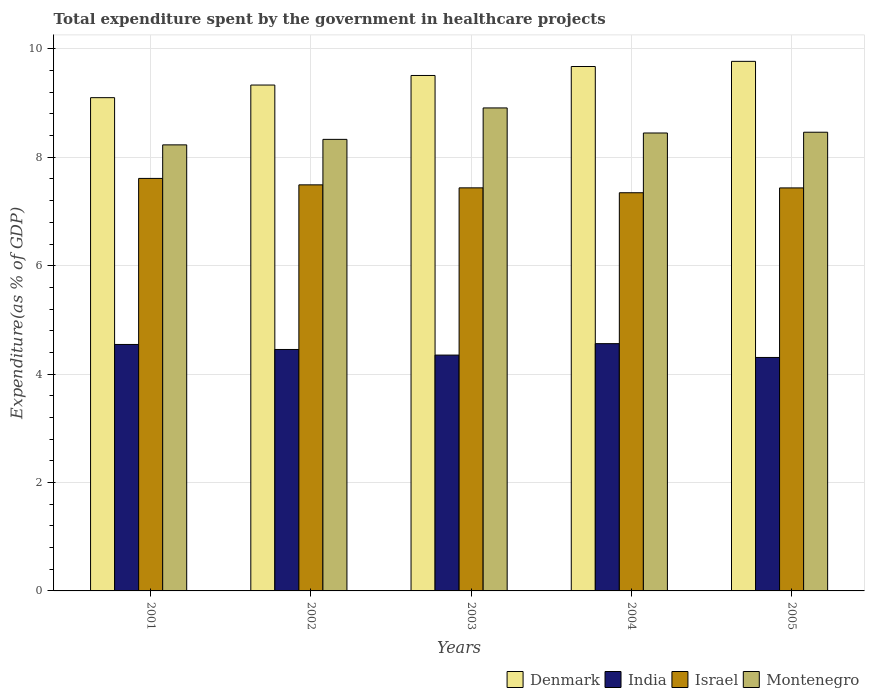How many bars are there on the 4th tick from the left?
Make the answer very short. 4. How many bars are there on the 4th tick from the right?
Offer a very short reply. 4. What is the total expenditure spent by the government in healthcare projects in Montenegro in 2001?
Provide a succinct answer. 8.23. Across all years, what is the maximum total expenditure spent by the government in healthcare projects in Montenegro?
Your answer should be very brief. 8.91. Across all years, what is the minimum total expenditure spent by the government in healthcare projects in Denmark?
Offer a very short reply. 9.1. In which year was the total expenditure spent by the government in healthcare projects in India maximum?
Keep it short and to the point. 2004. In which year was the total expenditure spent by the government in healthcare projects in Israel minimum?
Make the answer very short. 2004. What is the total total expenditure spent by the government in healthcare projects in India in the graph?
Provide a succinct answer. 22.22. What is the difference between the total expenditure spent by the government in healthcare projects in Israel in 2002 and that in 2005?
Give a very brief answer. 0.06. What is the difference between the total expenditure spent by the government in healthcare projects in India in 2003 and the total expenditure spent by the government in healthcare projects in Denmark in 2001?
Your response must be concise. -4.75. What is the average total expenditure spent by the government in healthcare projects in Denmark per year?
Provide a succinct answer. 9.48. In the year 2005, what is the difference between the total expenditure spent by the government in healthcare projects in Montenegro and total expenditure spent by the government in healthcare projects in Israel?
Offer a terse response. 1.03. What is the ratio of the total expenditure spent by the government in healthcare projects in Montenegro in 2004 to that in 2005?
Keep it short and to the point. 1. What is the difference between the highest and the second highest total expenditure spent by the government in healthcare projects in Denmark?
Make the answer very short. 0.1. What is the difference between the highest and the lowest total expenditure spent by the government in healthcare projects in Israel?
Keep it short and to the point. 0.26. Is the sum of the total expenditure spent by the government in healthcare projects in Denmark in 2002 and 2005 greater than the maximum total expenditure spent by the government in healthcare projects in India across all years?
Offer a terse response. Yes. What does the 1st bar from the left in 2004 represents?
Keep it short and to the point. Denmark. How many bars are there?
Give a very brief answer. 20. What is the difference between two consecutive major ticks on the Y-axis?
Offer a terse response. 2. Are the values on the major ticks of Y-axis written in scientific E-notation?
Your answer should be very brief. No. Does the graph contain any zero values?
Your answer should be very brief. No. Does the graph contain grids?
Offer a terse response. Yes. Where does the legend appear in the graph?
Ensure brevity in your answer.  Bottom right. How many legend labels are there?
Give a very brief answer. 4. What is the title of the graph?
Offer a terse response. Total expenditure spent by the government in healthcare projects. Does "Afghanistan" appear as one of the legend labels in the graph?
Keep it short and to the point. No. What is the label or title of the Y-axis?
Provide a succinct answer. Expenditure(as % of GDP). What is the Expenditure(as % of GDP) of Denmark in 2001?
Offer a terse response. 9.1. What is the Expenditure(as % of GDP) in India in 2001?
Your answer should be very brief. 4.55. What is the Expenditure(as % of GDP) in Israel in 2001?
Your response must be concise. 7.61. What is the Expenditure(as % of GDP) in Montenegro in 2001?
Your response must be concise. 8.23. What is the Expenditure(as % of GDP) of Denmark in 2002?
Keep it short and to the point. 9.33. What is the Expenditure(as % of GDP) of India in 2002?
Your answer should be compact. 4.45. What is the Expenditure(as % of GDP) in Israel in 2002?
Provide a short and direct response. 7.49. What is the Expenditure(as % of GDP) in Montenegro in 2002?
Ensure brevity in your answer.  8.33. What is the Expenditure(as % of GDP) in Denmark in 2003?
Make the answer very short. 9.51. What is the Expenditure(as % of GDP) of India in 2003?
Give a very brief answer. 4.35. What is the Expenditure(as % of GDP) in Israel in 2003?
Ensure brevity in your answer.  7.44. What is the Expenditure(as % of GDP) in Montenegro in 2003?
Keep it short and to the point. 8.91. What is the Expenditure(as % of GDP) of Denmark in 2004?
Your answer should be very brief. 9.67. What is the Expenditure(as % of GDP) of India in 2004?
Provide a succinct answer. 4.56. What is the Expenditure(as % of GDP) in Israel in 2004?
Your response must be concise. 7.35. What is the Expenditure(as % of GDP) in Montenegro in 2004?
Keep it short and to the point. 8.45. What is the Expenditure(as % of GDP) of Denmark in 2005?
Your response must be concise. 9.77. What is the Expenditure(as % of GDP) of India in 2005?
Your answer should be very brief. 4.31. What is the Expenditure(as % of GDP) of Israel in 2005?
Offer a very short reply. 7.44. What is the Expenditure(as % of GDP) of Montenegro in 2005?
Keep it short and to the point. 8.46. Across all years, what is the maximum Expenditure(as % of GDP) in Denmark?
Make the answer very short. 9.77. Across all years, what is the maximum Expenditure(as % of GDP) in India?
Your answer should be very brief. 4.56. Across all years, what is the maximum Expenditure(as % of GDP) in Israel?
Offer a terse response. 7.61. Across all years, what is the maximum Expenditure(as % of GDP) in Montenegro?
Provide a short and direct response. 8.91. Across all years, what is the minimum Expenditure(as % of GDP) of Denmark?
Make the answer very short. 9.1. Across all years, what is the minimum Expenditure(as % of GDP) in India?
Offer a terse response. 4.31. Across all years, what is the minimum Expenditure(as % of GDP) in Israel?
Make the answer very short. 7.35. Across all years, what is the minimum Expenditure(as % of GDP) of Montenegro?
Make the answer very short. 8.23. What is the total Expenditure(as % of GDP) in Denmark in the graph?
Your answer should be compact. 47.39. What is the total Expenditure(as % of GDP) of India in the graph?
Make the answer very short. 22.22. What is the total Expenditure(as % of GDP) in Israel in the graph?
Offer a very short reply. 37.32. What is the total Expenditure(as % of GDP) of Montenegro in the graph?
Offer a terse response. 42.38. What is the difference between the Expenditure(as % of GDP) in Denmark in 2001 and that in 2002?
Give a very brief answer. -0.23. What is the difference between the Expenditure(as % of GDP) of India in 2001 and that in 2002?
Ensure brevity in your answer.  0.09. What is the difference between the Expenditure(as % of GDP) of Israel in 2001 and that in 2002?
Keep it short and to the point. 0.12. What is the difference between the Expenditure(as % of GDP) of Montenegro in 2001 and that in 2002?
Ensure brevity in your answer.  -0.1. What is the difference between the Expenditure(as % of GDP) in Denmark in 2001 and that in 2003?
Provide a short and direct response. -0.41. What is the difference between the Expenditure(as % of GDP) of India in 2001 and that in 2003?
Offer a very short reply. 0.2. What is the difference between the Expenditure(as % of GDP) of Israel in 2001 and that in 2003?
Your answer should be compact. 0.17. What is the difference between the Expenditure(as % of GDP) of Montenegro in 2001 and that in 2003?
Offer a terse response. -0.68. What is the difference between the Expenditure(as % of GDP) in Denmark in 2001 and that in 2004?
Your answer should be compact. -0.57. What is the difference between the Expenditure(as % of GDP) of India in 2001 and that in 2004?
Your answer should be compact. -0.01. What is the difference between the Expenditure(as % of GDP) in Israel in 2001 and that in 2004?
Provide a short and direct response. 0.26. What is the difference between the Expenditure(as % of GDP) of Montenegro in 2001 and that in 2004?
Provide a succinct answer. -0.22. What is the difference between the Expenditure(as % of GDP) of Denmark in 2001 and that in 2005?
Your response must be concise. -0.67. What is the difference between the Expenditure(as % of GDP) in India in 2001 and that in 2005?
Your answer should be compact. 0.24. What is the difference between the Expenditure(as % of GDP) of Israel in 2001 and that in 2005?
Keep it short and to the point. 0.18. What is the difference between the Expenditure(as % of GDP) of Montenegro in 2001 and that in 2005?
Your response must be concise. -0.23. What is the difference between the Expenditure(as % of GDP) in Denmark in 2002 and that in 2003?
Give a very brief answer. -0.18. What is the difference between the Expenditure(as % of GDP) in India in 2002 and that in 2003?
Ensure brevity in your answer.  0.1. What is the difference between the Expenditure(as % of GDP) in Israel in 2002 and that in 2003?
Your answer should be very brief. 0.06. What is the difference between the Expenditure(as % of GDP) of Montenegro in 2002 and that in 2003?
Keep it short and to the point. -0.58. What is the difference between the Expenditure(as % of GDP) of Denmark in 2002 and that in 2004?
Provide a succinct answer. -0.34. What is the difference between the Expenditure(as % of GDP) in India in 2002 and that in 2004?
Your answer should be very brief. -0.11. What is the difference between the Expenditure(as % of GDP) of Israel in 2002 and that in 2004?
Ensure brevity in your answer.  0.15. What is the difference between the Expenditure(as % of GDP) of Montenegro in 2002 and that in 2004?
Ensure brevity in your answer.  -0.12. What is the difference between the Expenditure(as % of GDP) of Denmark in 2002 and that in 2005?
Keep it short and to the point. -0.44. What is the difference between the Expenditure(as % of GDP) of India in 2002 and that in 2005?
Provide a short and direct response. 0.15. What is the difference between the Expenditure(as % of GDP) in Israel in 2002 and that in 2005?
Offer a very short reply. 0.06. What is the difference between the Expenditure(as % of GDP) of Montenegro in 2002 and that in 2005?
Offer a terse response. -0.13. What is the difference between the Expenditure(as % of GDP) of Denmark in 2003 and that in 2004?
Offer a terse response. -0.17. What is the difference between the Expenditure(as % of GDP) in India in 2003 and that in 2004?
Offer a very short reply. -0.21. What is the difference between the Expenditure(as % of GDP) in Israel in 2003 and that in 2004?
Offer a very short reply. 0.09. What is the difference between the Expenditure(as % of GDP) in Montenegro in 2003 and that in 2004?
Give a very brief answer. 0.46. What is the difference between the Expenditure(as % of GDP) of Denmark in 2003 and that in 2005?
Your response must be concise. -0.26. What is the difference between the Expenditure(as % of GDP) of India in 2003 and that in 2005?
Offer a terse response. 0.04. What is the difference between the Expenditure(as % of GDP) of Israel in 2003 and that in 2005?
Your answer should be very brief. 0. What is the difference between the Expenditure(as % of GDP) of Montenegro in 2003 and that in 2005?
Ensure brevity in your answer.  0.45. What is the difference between the Expenditure(as % of GDP) in Denmark in 2004 and that in 2005?
Your response must be concise. -0.1. What is the difference between the Expenditure(as % of GDP) in India in 2004 and that in 2005?
Make the answer very short. 0.25. What is the difference between the Expenditure(as % of GDP) of Israel in 2004 and that in 2005?
Provide a short and direct response. -0.09. What is the difference between the Expenditure(as % of GDP) of Montenegro in 2004 and that in 2005?
Keep it short and to the point. -0.01. What is the difference between the Expenditure(as % of GDP) in Denmark in 2001 and the Expenditure(as % of GDP) in India in 2002?
Your response must be concise. 4.65. What is the difference between the Expenditure(as % of GDP) in Denmark in 2001 and the Expenditure(as % of GDP) in Israel in 2002?
Provide a succinct answer. 1.61. What is the difference between the Expenditure(as % of GDP) of Denmark in 2001 and the Expenditure(as % of GDP) of Montenegro in 2002?
Keep it short and to the point. 0.77. What is the difference between the Expenditure(as % of GDP) in India in 2001 and the Expenditure(as % of GDP) in Israel in 2002?
Give a very brief answer. -2.94. What is the difference between the Expenditure(as % of GDP) in India in 2001 and the Expenditure(as % of GDP) in Montenegro in 2002?
Provide a succinct answer. -3.78. What is the difference between the Expenditure(as % of GDP) of Israel in 2001 and the Expenditure(as % of GDP) of Montenegro in 2002?
Offer a terse response. -0.72. What is the difference between the Expenditure(as % of GDP) of Denmark in 2001 and the Expenditure(as % of GDP) of India in 2003?
Provide a succinct answer. 4.75. What is the difference between the Expenditure(as % of GDP) in Denmark in 2001 and the Expenditure(as % of GDP) in Israel in 2003?
Give a very brief answer. 1.66. What is the difference between the Expenditure(as % of GDP) in Denmark in 2001 and the Expenditure(as % of GDP) in Montenegro in 2003?
Provide a short and direct response. 0.19. What is the difference between the Expenditure(as % of GDP) of India in 2001 and the Expenditure(as % of GDP) of Israel in 2003?
Ensure brevity in your answer.  -2.89. What is the difference between the Expenditure(as % of GDP) in India in 2001 and the Expenditure(as % of GDP) in Montenegro in 2003?
Give a very brief answer. -4.36. What is the difference between the Expenditure(as % of GDP) of Israel in 2001 and the Expenditure(as % of GDP) of Montenegro in 2003?
Make the answer very short. -1.3. What is the difference between the Expenditure(as % of GDP) of Denmark in 2001 and the Expenditure(as % of GDP) of India in 2004?
Give a very brief answer. 4.54. What is the difference between the Expenditure(as % of GDP) of Denmark in 2001 and the Expenditure(as % of GDP) of Israel in 2004?
Make the answer very short. 1.75. What is the difference between the Expenditure(as % of GDP) in Denmark in 2001 and the Expenditure(as % of GDP) in Montenegro in 2004?
Ensure brevity in your answer.  0.65. What is the difference between the Expenditure(as % of GDP) in India in 2001 and the Expenditure(as % of GDP) in Israel in 2004?
Your answer should be compact. -2.8. What is the difference between the Expenditure(as % of GDP) of India in 2001 and the Expenditure(as % of GDP) of Montenegro in 2004?
Provide a short and direct response. -3.9. What is the difference between the Expenditure(as % of GDP) of Israel in 2001 and the Expenditure(as % of GDP) of Montenegro in 2004?
Ensure brevity in your answer.  -0.84. What is the difference between the Expenditure(as % of GDP) in Denmark in 2001 and the Expenditure(as % of GDP) in India in 2005?
Provide a short and direct response. 4.79. What is the difference between the Expenditure(as % of GDP) of Denmark in 2001 and the Expenditure(as % of GDP) of Israel in 2005?
Offer a very short reply. 1.67. What is the difference between the Expenditure(as % of GDP) in Denmark in 2001 and the Expenditure(as % of GDP) in Montenegro in 2005?
Provide a succinct answer. 0.64. What is the difference between the Expenditure(as % of GDP) of India in 2001 and the Expenditure(as % of GDP) of Israel in 2005?
Offer a terse response. -2.89. What is the difference between the Expenditure(as % of GDP) in India in 2001 and the Expenditure(as % of GDP) in Montenegro in 2005?
Provide a short and direct response. -3.92. What is the difference between the Expenditure(as % of GDP) in Israel in 2001 and the Expenditure(as % of GDP) in Montenegro in 2005?
Make the answer very short. -0.85. What is the difference between the Expenditure(as % of GDP) in Denmark in 2002 and the Expenditure(as % of GDP) in India in 2003?
Keep it short and to the point. 4.98. What is the difference between the Expenditure(as % of GDP) in Denmark in 2002 and the Expenditure(as % of GDP) in Israel in 2003?
Provide a succinct answer. 1.9. What is the difference between the Expenditure(as % of GDP) of Denmark in 2002 and the Expenditure(as % of GDP) of Montenegro in 2003?
Your answer should be compact. 0.42. What is the difference between the Expenditure(as % of GDP) of India in 2002 and the Expenditure(as % of GDP) of Israel in 2003?
Keep it short and to the point. -2.98. What is the difference between the Expenditure(as % of GDP) in India in 2002 and the Expenditure(as % of GDP) in Montenegro in 2003?
Provide a succinct answer. -4.46. What is the difference between the Expenditure(as % of GDP) in Israel in 2002 and the Expenditure(as % of GDP) in Montenegro in 2003?
Make the answer very short. -1.42. What is the difference between the Expenditure(as % of GDP) of Denmark in 2002 and the Expenditure(as % of GDP) of India in 2004?
Your response must be concise. 4.77. What is the difference between the Expenditure(as % of GDP) of Denmark in 2002 and the Expenditure(as % of GDP) of Israel in 2004?
Offer a terse response. 1.99. What is the difference between the Expenditure(as % of GDP) of Denmark in 2002 and the Expenditure(as % of GDP) of Montenegro in 2004?
Provide a succinct answer. 0.88. What is the difference between the Expenditure(as % of GDP) in India in 2002 and the Expenditure(as % of GDP) in Israel in 2004?
Give a very brief answer. -2.89. What is the difference between the Expenditure(as % of GDP) in India in 2002 and the Expenditure(as % of GDP) in Montenegro in 2004?
Offer a very short reply. -3.99. What is the difference between the Expenditure(as % of GDP) of Israel in 2002 and the Expenditure(as % of GDP) of Montenegro in 2004?
Keep it short and to the point. -0.96. What is the difference between the Expenditure(as % of GDP) of Denmark in 2002 and the Expenditure(as % of GDP) of India in 2005?
Provide a succinct answer. 5.03. What is the difference between the Expenditure(as % of GDP) of Denmark in 2002 and the Expenditure(as % of GDP) of Israel in 2005?
Your answer should be very brief. 1.9. What is the difference between the Expenditure(as % of GDP) of Denmark in 2002 and the Expenditure(as % of GDP) of Montenegro in 2005?
Provide a short and direct response. 0.87. What is the difference between the Expenditure(as % of GDP) in India in 2002 and the Expenditure(as % of GDP) in Israel in 2005?
Your answer should be very brief. -2.98. What is the difference between the Expenditure(as % of GDP) in India in 2002 and the Expenditure(as % of GDP) in Montenegro in 2005?
Your answer should be very brief. -4.01. What is the difference between the Expenditure(as % of GDP) of Israel in 2002 and the Expenditure(as % of GDP) of Montenegro in 2005?
Your response must be concise. -0.97. What is the difference between the Expenditure(as % of GDP) of Denmark in 2003 and the Expenditure(as % of GDP) of India in 2004?
Your response must be concise. 4.95. What is the difference between the Expenditure(as % of GDP) of Denmark in 2003 and the Expenditure(as % of GDP) of Israel in 2004?
Your answer should be very brief. 2.16. What is the difference between the Expenditure(as % of GDP) of Denmark in 2003 and the Expenditure(as % of GDP) of Montenegro in 2004?
Your answer should be very brief. 1.06. What is the difference between the Expenditure(as % of GDP) of India in 2003 and the Expenditure(as % of GDP) of Israel in 2004?
Offer a very short reply. -3. What is the difference between the Expenditure(as % of GDP) of India in 2003 and the Expenditure(as % of GDP) of Montenegro in 2004?
Offer a terse response. -4.1. What is the difference between the Expenditure(as % of GDP) in Israel in 2003 and the Expenditure(as % of GDP) in Montenegro in 2004?
Ensure brevity in your answer.  -1.01. What is the difference between the Expenditure(as % of GDP) of Denmark in 2003 and the Expenditure(as % of GDP) of India in 2005?
Provide a succinct answer. 5.2. What is the difference between the Expenditure(as % of GDP) in Denmark in 2003 and the Expenditure(as % of GDP) in Israel in 2005?
Your response must be concise. 2.07. What is the difference between the Expenditure(as % of GDP) of Denmark in 2003 and the Expenditure(as % of GDP) of Montenegro in 2005?
Give a very brief answer. 1.05. What is the difference between the Expenditure(as % of GDP) in India in 2003 and the Expenditure(as % of GDP) in Israel in 2005?
Provide a short and direct response. -3.08. What is the difference between the Expenditure(as % of GDP) of India in 2003 and the Expenditure(as % of GDP) of Montenegro in 2005?
Make the answer very short. -4.11. What is the difference between the Expenditure(as % of GDP) in Israel in 2003 and the Expenditure(as % of GDP) in Montenegro in 2005?
Your answer should be very brief. -1.03. What is the difference between the Expenditure(as % of GDP) of Denmark in 2004 and the Expenditure(as % of GDP) of India in 2005?
Offer a very short reply. 5.37. What is the difference between the Expenditure(as % of GDP) in Denmark in 2004 and the Expenditure(as % of GDP) in Israel in 2005?
Provide a short and direct response. 2.24. What is the difference between the Expenditure(as % of GDP) of Denmark in 2004 and the Expenditure(as % of GDP) of Montenegro in 2005?
Offer a terse response. 1.21. What is the difference between the Expenditure(as % of GDP) of India in 2004 and the Expenditure(as % of GDP) of Israel in 2005?
Your answer should be very brief. -2.87. What is the difference between the Expenditure(as % of GDP) of India in 2004 and the Expenditure(as % of GDP) of Montenegro in 2005?
Offer a very short reply. -3.9. What is the difference between the Expenditure(as % of GDP) of Israel in 2004 and the Expenditure(as % of GDP) of Montenegro in 2005?
Offer a terse response. -1.12. What is the average Expenditure(as % of GDP) of Denmark per year?
Give a very brief answer. 9.48. What is the average Expenditure(as % of GDP) of India per year?
Your answer should be very brief. 4.44. What is the average Expenditure(as % of GDP) of Israel per year?
Your answer should be compact. 7.46. What is the average Expenditure(as % of GDP) of Montenegro per year?
Keep it short and to the point. 8.48. In the year 2001, what is the difference between the Expenditure(as % of GDP) of Denmark and Expenditure(as % of GDP) of India?
Make the answer very short. 4.55. In the year 2001, what is the difference between the Expenditure(as % of GDP) in Denmark and Expenditure(as % of GDP) in Israel?
Give a very brief answer. 1.49. In the year 2001, what is the difference between the Expenditure(as % of GDP) in Denmark and Expenditure(as % of GDP) in Montenegro?
Make the answer very short. 0.87. In the year 2001, what is the difference between the Expenditure(as % of GDP) in India and Expenditure(as % of GDP) in Israel?
Your answer should be very brief. -3.06. In the year 2001, what is the difference between the Expenditure(as % of GDP) in India and Expenditure(as % of GDP) in Montenegro?
Provide a succinct answer. -3.68. In the year 2001, what is the difference between the Expenditure(as % of GDP) in Israel and Expenditure(as % of GDP) in Montenegro?
Offer a terse response. -0.62. In the year 2002, what is the difference between the Expenditure(as % of GDP) in Denmark and Expenditure(as % of GDP) in India?
Make the answer very short. 4.88. In the year 2002, what is the difference between the Expenditure(as % of GDP) of Denmark and Expenditure(as % of GDP) of Israel?
Offer a terse response. 1.84. In the year 2002, what is the difference between the Expenditure(as % of GDP) in India and Expenditure(as % of GDP) in Israel?
Your answer should be very brief. -3.04. In the year 2002, what is the difference between the Expenditure(as % of GDP) in India and Expenditure(as % of GDP) in Montenegro?
Provide a succinct answer. -3.88. In the year 2002, what is the difference between the Expenditure(as % of GDP) of Israel and Expenditure(as % of GDP) of Montenegro?
Offer a very short reply. -0.84. In the year 2003, what is the difference between the Expenditure(as % of GDP) of Denmark and Expenditure(as % of GDP) of India?
Provide a succinct answer. 5.16. In the year 2003, what is the difference between the Expenditure(as % of GDP) of Denmark and Expenditure(as % of GDP) of Israel?
Your answer should be compact. 2.07. In the year 2003, what is the difference between the Expenditure(as % of GDP) in Denmark and Expenditure(as % of GDP) in Montenegro?
Offer a terse response. 0.6. In the year 2003, what is the difference between the Expenditure(as % of GDP) of India and Expenditure(as % of GDP) of Israel?
Provide a succinct answer. -3.09. In the year 2003, what is the difference between the Expenditure(as % of GDP) of India and Expenditure(as % of GDP) of Montenegro?
Offer a terse response. -4.56. In the year 2003, what is the difference between the Expenditure(as % of GDP) of Israel and Expenditure(as % of GDP) of Montenegro?
Make the answer very short. -1.47. In the year 2004, what is the difference between the Expenditure(as % of GDP) in Denmark and Expenditure(as % of GDP) in India?
Provide a short and direct response. 5.11. In the year 2004, what is the difference between the Expenditure(as % of GDP) of Denmark and Expenditure(as % of GDP) of Israel?
Your answer should be compact. 2.33. In the year 2004, what is the difference between the Expenditure(as % of GDP) of Denmark and Expenditure(as % of GDP) of Montenegro?
Ensure brevity in your answer.  1.23. In the year 2004, what is the difference between the Expenditure(as % of GDP) of India and Expenditure(as % of GDP) of Israel?
Ensure brevity in your answer.  -2.78. In the year 2004, what is the difference between the Expenditure(as % of GDP) in India and Expenditure(as % of GDP) in Montenegro?
Provide a succinct answer. -3.89. In the year 2004, what is the difference between the Expenditure(as % of GDP) in Israel and Expenditure(as % of GDP) in Montenegro?
Your answer should be very brief. -1.1. In the year 2005, what is the difference between the Expenditure(as % of GDP) in Denmark and Expenditure(as % of GDP) in India?
Make the answer very short. 5.46. In the year 2005, what is the difference between the Expenditure(as % of GDP) in Denmark and Expenditure(as % of GDP) in Israel?
Offer a very short reply. 2.33. In the year 2005, what is the difference between the Expenditure(as % of GDP) of Denmark and Expenditure(as % of GDP) of Montenegro?
Provide a succinct answer. 1.31. In the year 2005, what is the difference between the Expenditure(as % of GDP) in India and Expenditure(as % of GDP) in Israel?
Offer a very short reply. -3.13. In the year 2005, what is the difference between the Expenditure(as % of GDP) of India and Expenditure(as % of GDP) of Montenegro?
Your response must be concise. -4.16. In the year 2005, what is the difference between the Expenditure(as % of GDP) of Israel and Expenditure(as % of GDP) of Montenegro?
Your response must be concise. -1.03. What is the ratio of the Expenditure(as % of GDP) in Denmark in 2001 to that in 2002?
Ensure brevity in your answer.  0.98. What is the ratio of the Expenditure(as % of GDP) in India in 2001 to that in 2002?
Ensure brevity in your answer.  1.02. What is the ratio of the Expenditure(as % of GDP) of Israel in 2001 to that in 2002?
Your response must be concise. 1.02. What is the ratio of the Expenditure(as % of GDP) of Denmark in 2001 to that in 2003?
Offer a terse response. 0.96. What is the ratio of the Expenditure(as % of GDP) in India in 2001 to that in 2003?
Give a very brief answer. 1.05. What is the ratio of the Expenditure(as % of GDP) in Israel in 2001 to that in 2003?
Keep it short and to the point. 1.02. What is the ratio of the Expenditure(as % of GDP) in Montenegro in 2001 to that in 2003?
Provide a succinct answer. 0.92. What is the ratio of the Expenditure(as % of GDP) in Denmark in 2001 to that in 2004?
Provide a succinct answer. 0.94. What is the ratio of the Expenditure(as % of GDP) in India in 2001 to that in 2004?
Offer a terse response. 1. What is the ratio of the Expenditure(as % of GDP) in Israel in 2001 to that in 2004?
Your answer should be compact. 1.04. What is the ratio of the Expenditure(as % of GDP) of Montenegro in 2001 to that in 2004?
Offer a very short reply. 0.97. What is the ratio of the Expenditure(as % of GDP) in Denmark in 2001 to that in 2005?
Give a very brief answer. 0.93. What is the ratio of the Expenditure(as % of GDP) in India in 2001 to that in 2005?
Your answer should be very brief. 1.06. What is the ratio of the Expenditure(as % of GDP) in Israel in 2001 to that in 2005?
Offer a very short reply. 1.02. What is the ratio of the Expenditure(as % of GDP) of Montenegro in 2001 to that in 2005?
Ensure brevity in your answer.  0.97. What is the ratio of the Expenditure(as % of GDP) of Denmark in 2002 to that in 2003?
Offer a very short reply. 0.98. What is the ratio of the Expenditure(as % of GDP) in India in 2002 to that in 2003?
Offer a terse response. 1.02. What is the ratio of the Expenditure(as % of GDP) in Israel in 2002 to that in 2003?
Make the answer very short. 1.01. What is the ratio of the Expenditure(as % of GDP) in Montenegro in 2002 to that in 2003?
Offer a terse response. 0.93. What is the ratio of the Expenditure(as % of GDP) of Denmark in 2002 to that in 2004?
Make the answer very short. 0.96. What is the ratio of the Expenditure(as % of GDP) of India in 2002 to that in 2004?
Give a very brief answer. 0.98. What is the ratio of the Expenditure(as % of GDP) in Israel in 2002 to that in 2004?
Your answer should be very brief. 1.02. What is the ratio of the Expenditure(as % of GDP) in Montenegro in 2002 to that in 2004?
Your answer should be very brief. 0.99. What is the ratio of the Expenditure(as % of GDP) of Denmark in 2002 to that in 2005?
Keep it short and to the point. 0.96. What is the ratio of the Expenditure(as % of GDP) in India in 2002 to that in 2005?
Your response must be concise. 1.03. What is the ratio of the Expenditure(as % of GDP) of Israel in 2002 to that in 2005?
Provide a succinct answer. 1.01. What is the ratio of the Expenditure(as % of GDP) of Montenegro in 2002 to that in 2005?
Give a very brief answer. 0.98. What is the ratio of the Expenditure(as % of GDP) in Denmark in 2003 to that in 2004?
Offer a very short reply. 0.98. What is the ratio of the Expenditure(as % of GDP) in India in 2003 to that in 2004?
Provide a short and direct response. 0.95. What is the ratio of the Expenditure(as % of GDP) of Israel in 2003 to that in 2004?
Your answer should be very brief. 1.01. What is the ratio of the Expenditure(as % of GDP) in Montenegro in 2003 to that in 2004?
Ensure brevity in your answer.  1.05. What is the ratio of the Expenditure(as % of GDP) of Denmark in 2003 to that in 2005?
Offer a terse response. 0.97. What is the ratio of the Expenditure(as % of GDP) of India in 2003 to that in 2005?
Make the answer very short. 1.01. What is the ratio of the Expenditure(as % of GDP) in Montenegro in 2003 to that in 2005?
Your answer should be compact. 1.05. What is the ratio of the Expenditure(as % of GDP) in Denmark in 2004 to that in 2005?
Provide a succinct answer. 0.99. What is the ratio of the Expenditure(as % of GDP) in India in 2004 to that in 2005?
Your answer should be compact. 1.06. What is the difference between the highest and the second highest Expenditure(as % of GDP) of Denmark?
Offer a terse response. 0.1. What is the difference between the highest and the second highest Expenditure(as % of GDP) in India?
Your answer should be compact. 0.01. What is the difference between the highest and the second highest Expenditure(as % of GDP) of Israel?
Your response must be concise. 0.12. What is the difference between the highest and the second highest Expenditure(as % of GDP) of Montenegro?
Give a very brief answer. 0.45. What is the difference between the highest and the lowest Expenditure(as % of GDP) in Denmark?
Provide a short and direct response. 0.67. What is the difference between the highest and the lowest Expenditure(as % of GDP) of India?
Offer a very short reply. 0.25. What is the difference between the highest and the lowest Expenditure(as % of GDP) in Israel?
Your answer should be compact. 0.26. What is the difference between the highest and the lowest Expenditure(as % of GDP) in Montenegro?
Keep it short and to the point. 0.68. 